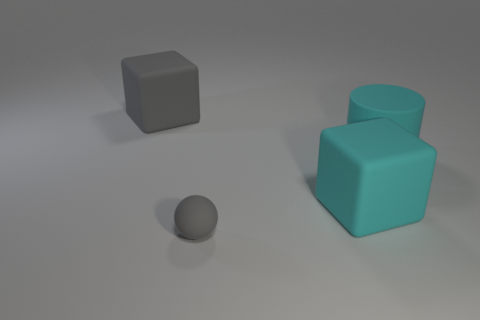Add 1 small gray rubber things. How many small gray rubber things are left? 2 Add 4 green metal things. How many green metal things exist? 4 Add 2 big green shiny cylinders. How many objects exist? 6 Subtract all gray blocks. How many blocks are left? 1 Subtract 0 cyan spheres. How many objects are left? 4 Subtract all cylinders. How many objects are left? 3 Subtract all purple blocks. Subtract all cyan cylinders. How many blocks are left? 2 Subtract all green cylinders. How many gray blocks are left? 1 Subtract all large gray things. Subtract all big cyan rubber objects. How many objects are left? 1 